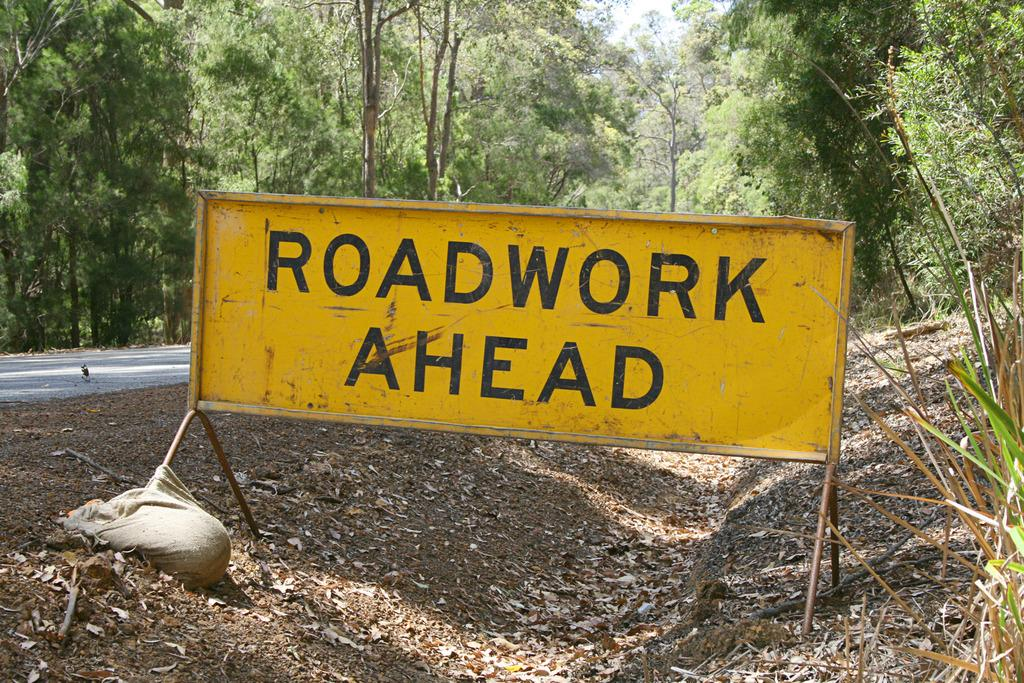What is the main object in the image? There is a yellow color board in the image. What type of material is visible in the image? There is cloth visible in the image. What type of natural environment is present in the image? There is grass in the image. What can be seen to the left of the image? There is a road to the left of the image. What is visible in the background of the image? There are many trees and the sky in the background of the image. What type of leather material can be seen on the color board in the image? There is no leather material present on the color board in the image; it is a yellow color board made of a different material. 